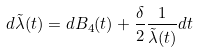<formula> <loc_0><loc_0><loc_500><loc_500>d \tilde { \lambda } ( t ) = d B _ { 4 } ( t ) + \frac { \delta } { 2 } \frac { 1 } { \tilde { \lambda } ( t ) } d t</formula> 